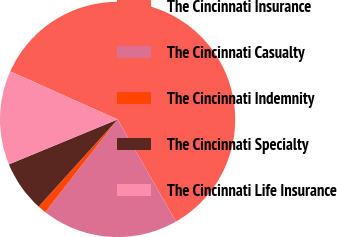<chart> <loc_0><loc_0><loc_500><loc_500><pie_chart><fcel>The Cincinnati Insurance<fcel>The Cincinnati Casualty<fcel>The Cincinnati Indemnity<fcel>The Cincinnati Specialty<fcel>The Cincinnati Life Insurance<nl><fcel>60.02%<fcel>18.82%<fcel>1.17%<fcel>7.05%<fcel>12.94%<nl></chart> 